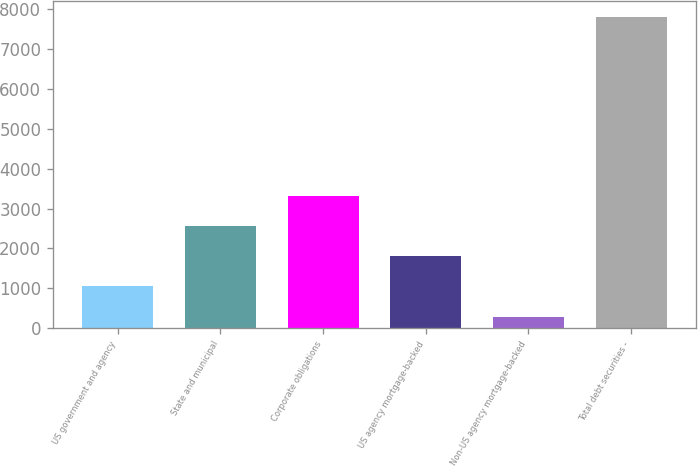<chart> <loc_0><loc_0><loc_500><loc_500><bar_chart><fcel>US government and agency<fcel>State and municipal<fcel>Corporate obligations<fcel>US agency mortgage-backed<fcel>Non-US agency mortgage-backed<fcel>Total debt securities -<nl><fcel>1055<fcel>2557.4<fcel>3308.6<fcel>1806.2<fcel>289<fcel>7801<nl></chart> 